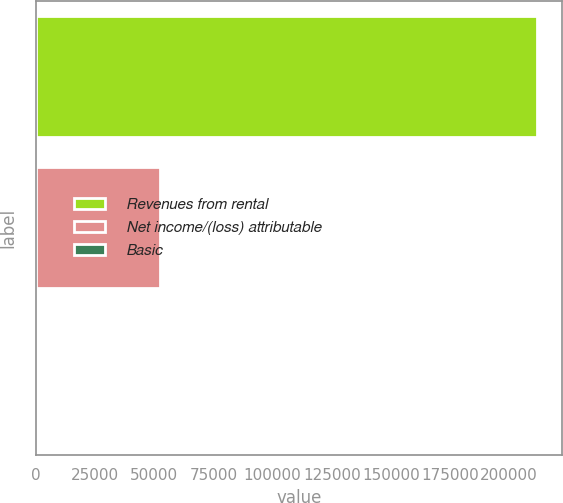Convert chart. <chart><loc_0><loc_0><loc_500><loc_500><bar_chart><fcel>Revenues from rental<fcel>Net income/(loss) attributable<fcel>Basic<nl><fcel>211822<fcel>52177<fcel>0.11<nl></chart> 